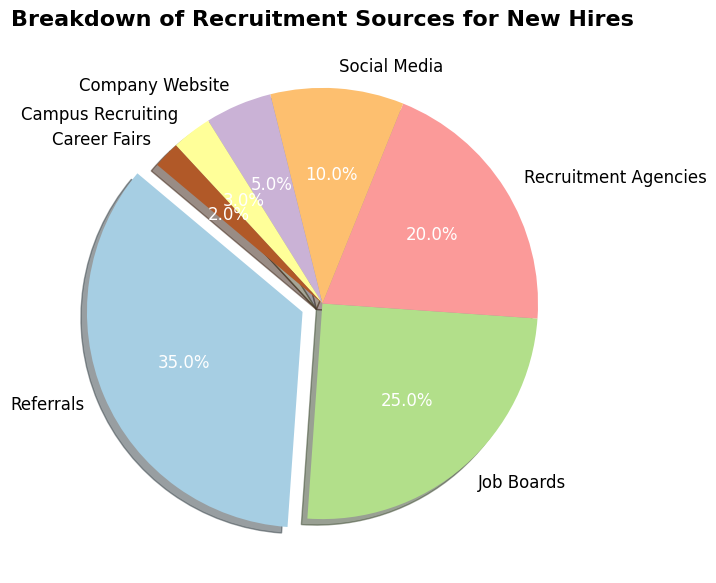What is the largest recruitment source? By observing the pie chart, the largest slice is clearly labeled, which corresponds to 'Referrals'. It is emphasized by an exploded segment making it easy to identify.
Answer: Referrals What percentage of new hires were sourced from Job Boards and Recruitment Agencies combined? By adding the percentages from the pie chart for 'Job Boards' (25%) and 'Recruitment Agencies' (20%), we get the sum of 25% + 20% = 45%.
Answer: 45% Which recruitment source has a smaller percentage: Social Media or Company Website? By comparing the slices labeled 'Social Media' (10%) and 'Company Website' (5%), it's evident that the Company Website has a smaller percentage.
Answer: Company Website How does the percentage from Campus Recruiting compare with Career Fairs? By looking at the pie chart, the segment for 'Campus Recruiting' (3%) is larger than that of 'Career Fairs' (2%), indicating Campus Recruiting has a higher percentage.
Answer: Campus Recruiting What is the sum of the percentages for the three smallest recruitment sources? Adding the percentages from the pie chart for 'Campus Recruiting' (3%), 'Career Fairs' (2%), and 'Company Website' (5%) gives 3% + 2% + 5% = 10%.
Answer: 10% Which sources constitute more than half of all new hires collectively? By summing the percentages of the largest slices, 'Referrals' (35%) and 'Job Boards' (25%) together, we get 35% + 25% = 60%, which is more than half.
Answer: Referrals and Job Boards If an organization were to focus on increasing its recruitment through its smallest two sources, which would they be? By identifying the slices with the smallest percentages, we see 'Career Fairs' (2%) and 'Campus Recruiting' (3%) are the smallest.
Answer: Career Fairs and Campus Recruiting What's the difference in percentage between the largest and third-largest recruitment sources? The percentages for 'Referrals' (35%) and 'Recruitment Agencies' (20%) are observed. The difference is 35% - 20% = 15%.
Answer: 15% How many sources contribute to more than 15% each to new hires? By scanning the pie chart, 'Referrals' (35%) and 'Job Boards' (25%) are the only slices that exceed 15%. Therefore, there are two sources.
Answer: 2 Which sources have percentages displayed in white text in the chart? Larger segments like 'Referrals' (35%), 'Job Boards' (25%), and 'Recruitment Agencies' (20%) have percentages in white text as they stand out with a darker background for better readability.
Answer: Referrals, Job Boards, Recruitment Agencies 